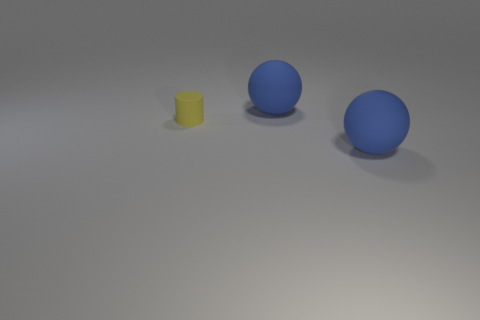Are there any big spheres that have the same color as the small object?
Offer a terse response. No. There is a yellow rubber thing; is it the same shape as the big blue object that is behind the yellow object?
Keep it short and to the point. No. How many other things are there of the same size as the cylinder?
Offer a very short reply. 0. Is the number of big gray metallic balls greater than the number of balls?
Keep it short and to the point. No. How many rubber spheres are both in front of the yellow thing and behind the tiny cylinder?
Offer a terse response. 0. The big blue rubber object that is behind the large matte object in front of the big rubber ball that is behind the small yellow rubber cylinder is what shape?
Provide a succinct answer. Sphere. Is there anything else that has the same shape as the tiny object?
Ensure brevity in your answer.  No. How many cylinders are either rubber objects or yellow matte things?
Provide a short and direct response. 1. There is a ball in front of the yellow cylinder; does it have the same color as the rubber cylinder?
Offer a very short reply. No. There is a yellow cylinder that is to the left of the blue object that is behind the yellow rubber cylinder; what is its size?
Your answer should be compact. Small. 